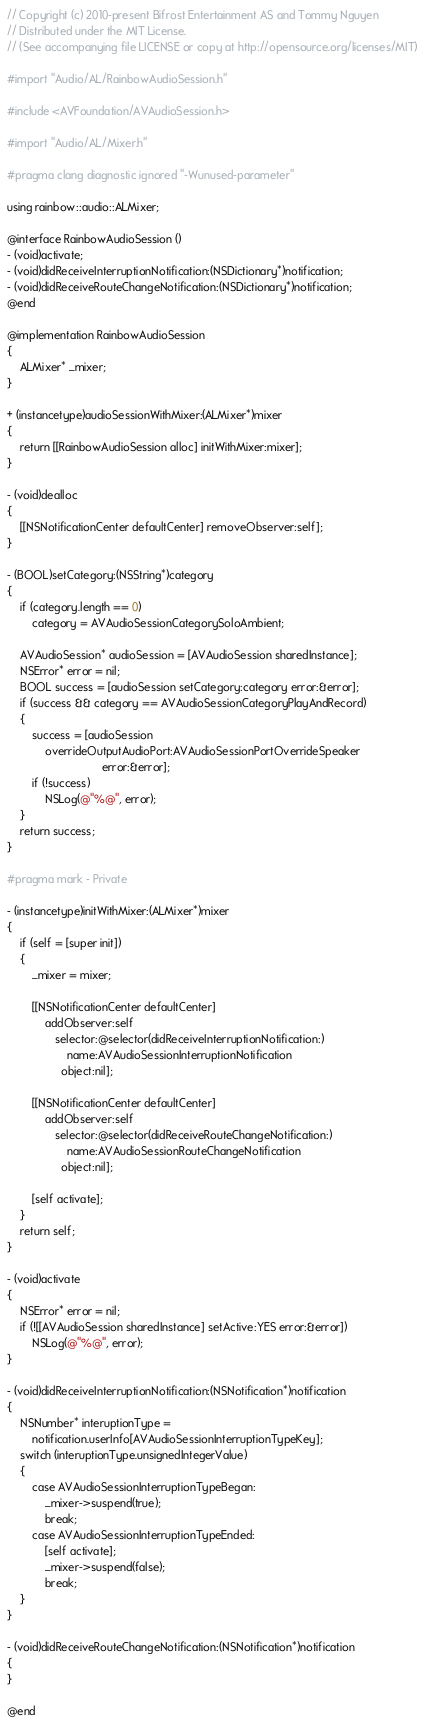<code> <loc_0><loc_0><loc_500><loc_500><_ObjectiveC_>// Copyright (c) 2010-present Bifrost Entertainment AS and Tommy Nguyen
// Distributed under the MIT License.
// (See accompanying file LICENSE or copy at http://opensource.org/licenses/MIT)

#import "Audio/AL/RainbowAudioSession.h"

#include <AVFoundation/AVAudioSession.h>

#import "Audio/AL/Mixer.h"

#pragma clang diagnostic ignored "-Wunused-parameter"

using rainbow::audio::ALMixer;

@interface RainbowAudioSession ()
- (void)activate;
- (void)didReceiveInterruptionNotification:(NSDictionary*)notification;
- (void)didReceiveRouteChangeNotification:(NSDictionary*)notification;
@end

@implementation RainbowAudioSession
{
    ALMixer* _mixer;
}

+ (instancetype)audioSessionWithMixer:(ALMixer*)mixer
{
    return [[RainbowAudioSession alloc] initWithMixer:mixer];
}

- (void)dealloc
{
    [[NSNotificationCenter defaultCenter] removeObserver:self];
}

- (BOOL)setCategory:(NSString*)category
{
    if (category.length == 0)
        category = AVAudioSessionCategorySoloAmbient;

    AVAudioSession* audioSession = [AVAudioSession sharedInstance];
    NSError* error = nil;
    BOOL success = [audioSession setCategory:category error:&error];
    if (success && category == AVAudioSessionCategoryPlayAndRecord)
    {
        success = [audioSession
            overrideOutputAudioPort:AVAudioSessionPortOverrideSpeaker
                              error:&error];
        if (!success)
            NSLog(@"%@", error);
    }
    return success;
}

#pragma mark - Private

- (instancetype)initWithMixer:(ALMixer*)mixer
{
    if (self = [super init])
    {
        _mixer = mixer;

        [[NSNotificationCenter defaultCenter]
            addObserver:self
               selector:@selector(didReceiveInterruptionNotification:)
                   name:AVAudioSessionInterruptionNotification
                 object:nil];

        [[NSNotificationCenter defaultCenter]
            addObserver:self
               selector:@selector(didReceiveRouteChangeNotification:)
                   name:AVAudioSessionRouteChangeNotification
                 object:nil];

        [self activate];
    }
    return self;
}

- (void)activate
{
    NSError* error = nil;
    if (![[AVAudioSession sharedInstance] setActive:YES error:&error])
        NSLog(@"%@", error);
}

- (void)didReceiveInterruptionNotification:(NSNotification*)notification
{
    NSNumber* interuptionType =
        notification.userInfo[AVAudioSessionInterruptionTypeKey];
    switch (interuptionType.unsignedIntegerValue)
    {
        case AVAudioSessionInterruptionTypeBegan:
            _mixer->suspend(true);
            break;
        case AVAudioSessionInterruptionTypeEnded:
            [self activate];
            _mixer->suspend(false);
            break;
    }
}

- (void)didReceiveRouteChangeNotification:(NSNotification*)notification
{
}

@end
</code> 